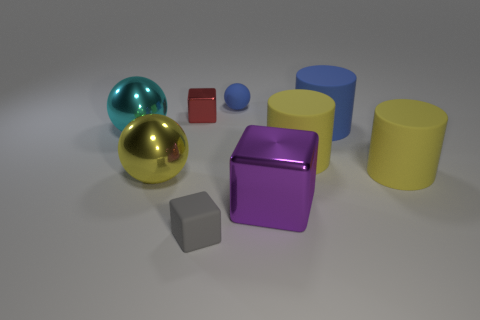Subtract all blue rubber cylinders. How many cylinders are left? 2 Subtract all yellow balls. How many balls are left? 2 Subtract all cylinders. How many objects are left? 6 Subtract 1 cylinders. How many cylinders are left? 2 Subtract 0 gray spheres. How many objects are left? 9 Subtract all red cylinders. Subtract all red balls. How many cylinders are left? 3 Subtract all green spheres. How many gray cubes are left? 1 Subtract all small balls. Subtract all purple metal things. How many objects are left? 7 Add 8 large cubes. How many large cubes are left? 9 Add 8 tiny red things. How many tiny red things exist? 9 